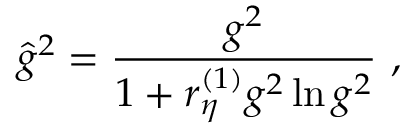Convert formula to latex. <formula><loc_0><loc_0><loc_500><loc_500>{ \hat { g } } ^ { 2 } = \frac { g ^ { 2 } } { 1 + r _ { \eta } ^ { ( 1 ) } g ^ { 2 } \ln g ^ { 2 } } \ ,</formula> 